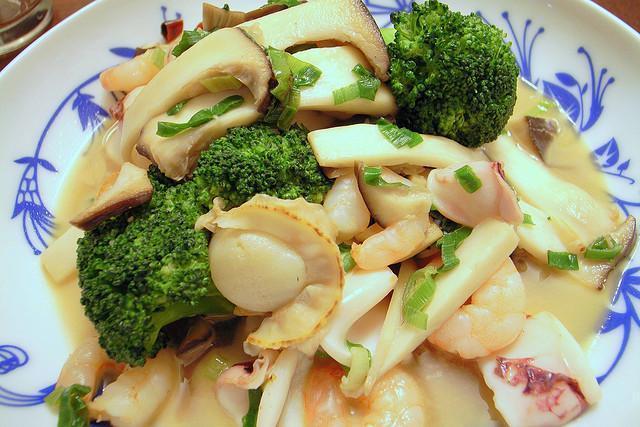How many broccolis are in the picture?
Give a very brief answer. 2. 